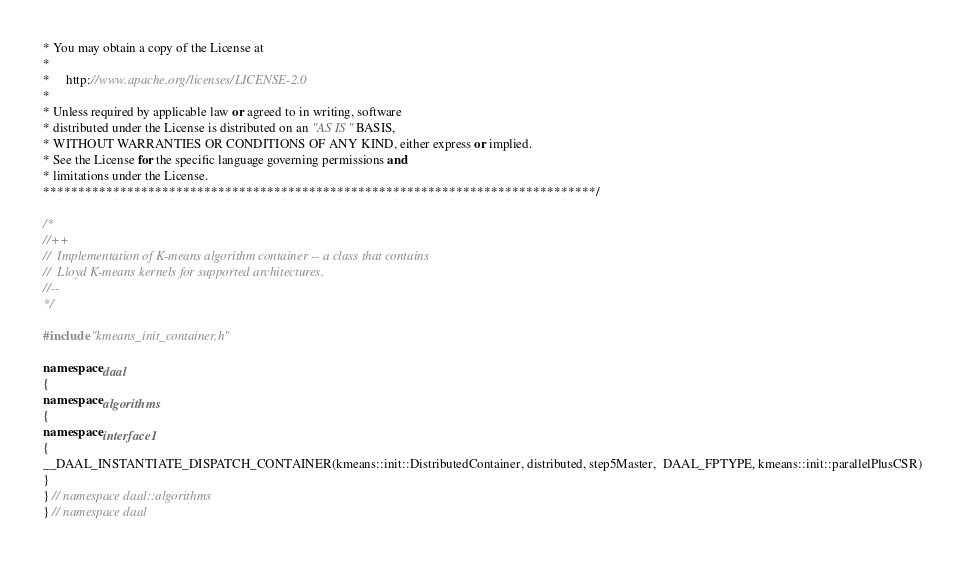Convert code to text. <code><loc_0><loc_0><loc_500><loc_500><_C++_>* You may obtain a copy of the License at
*
*     http://www.apache.org/licenses/LICENSE-2.0
*
* Unless required by applicable law or agreed to in writing, software
* distributed under the License is distributed on an "AS IS" BASIS,
* WITHOUT WARRANTIES OR CONDITIONS OF ANY KIND, either express or implied.
* See the License for the specific language governing permissions and
* limitations under the License.
*******************************************************************************/

/*
//++
//  Implementation of K-means algorithm container -- a class that contains
//  Lloyd K-means kernels for supported architectures.
//--
*/

#include "kmeans_init_container.h"

namespace daal
{
namespace algorithms
{
namespace interface1
{
__DAAL_INSTANTIATE_DISPATCH_CONTAINER(kmeans::init::DistributedContainer, distributed, step5Master,  DAAL_FPTYPE, kmeans::init::parallelPlusCSR)
}
} // namespace daal::algorithms
} // namespace daal
</code> 